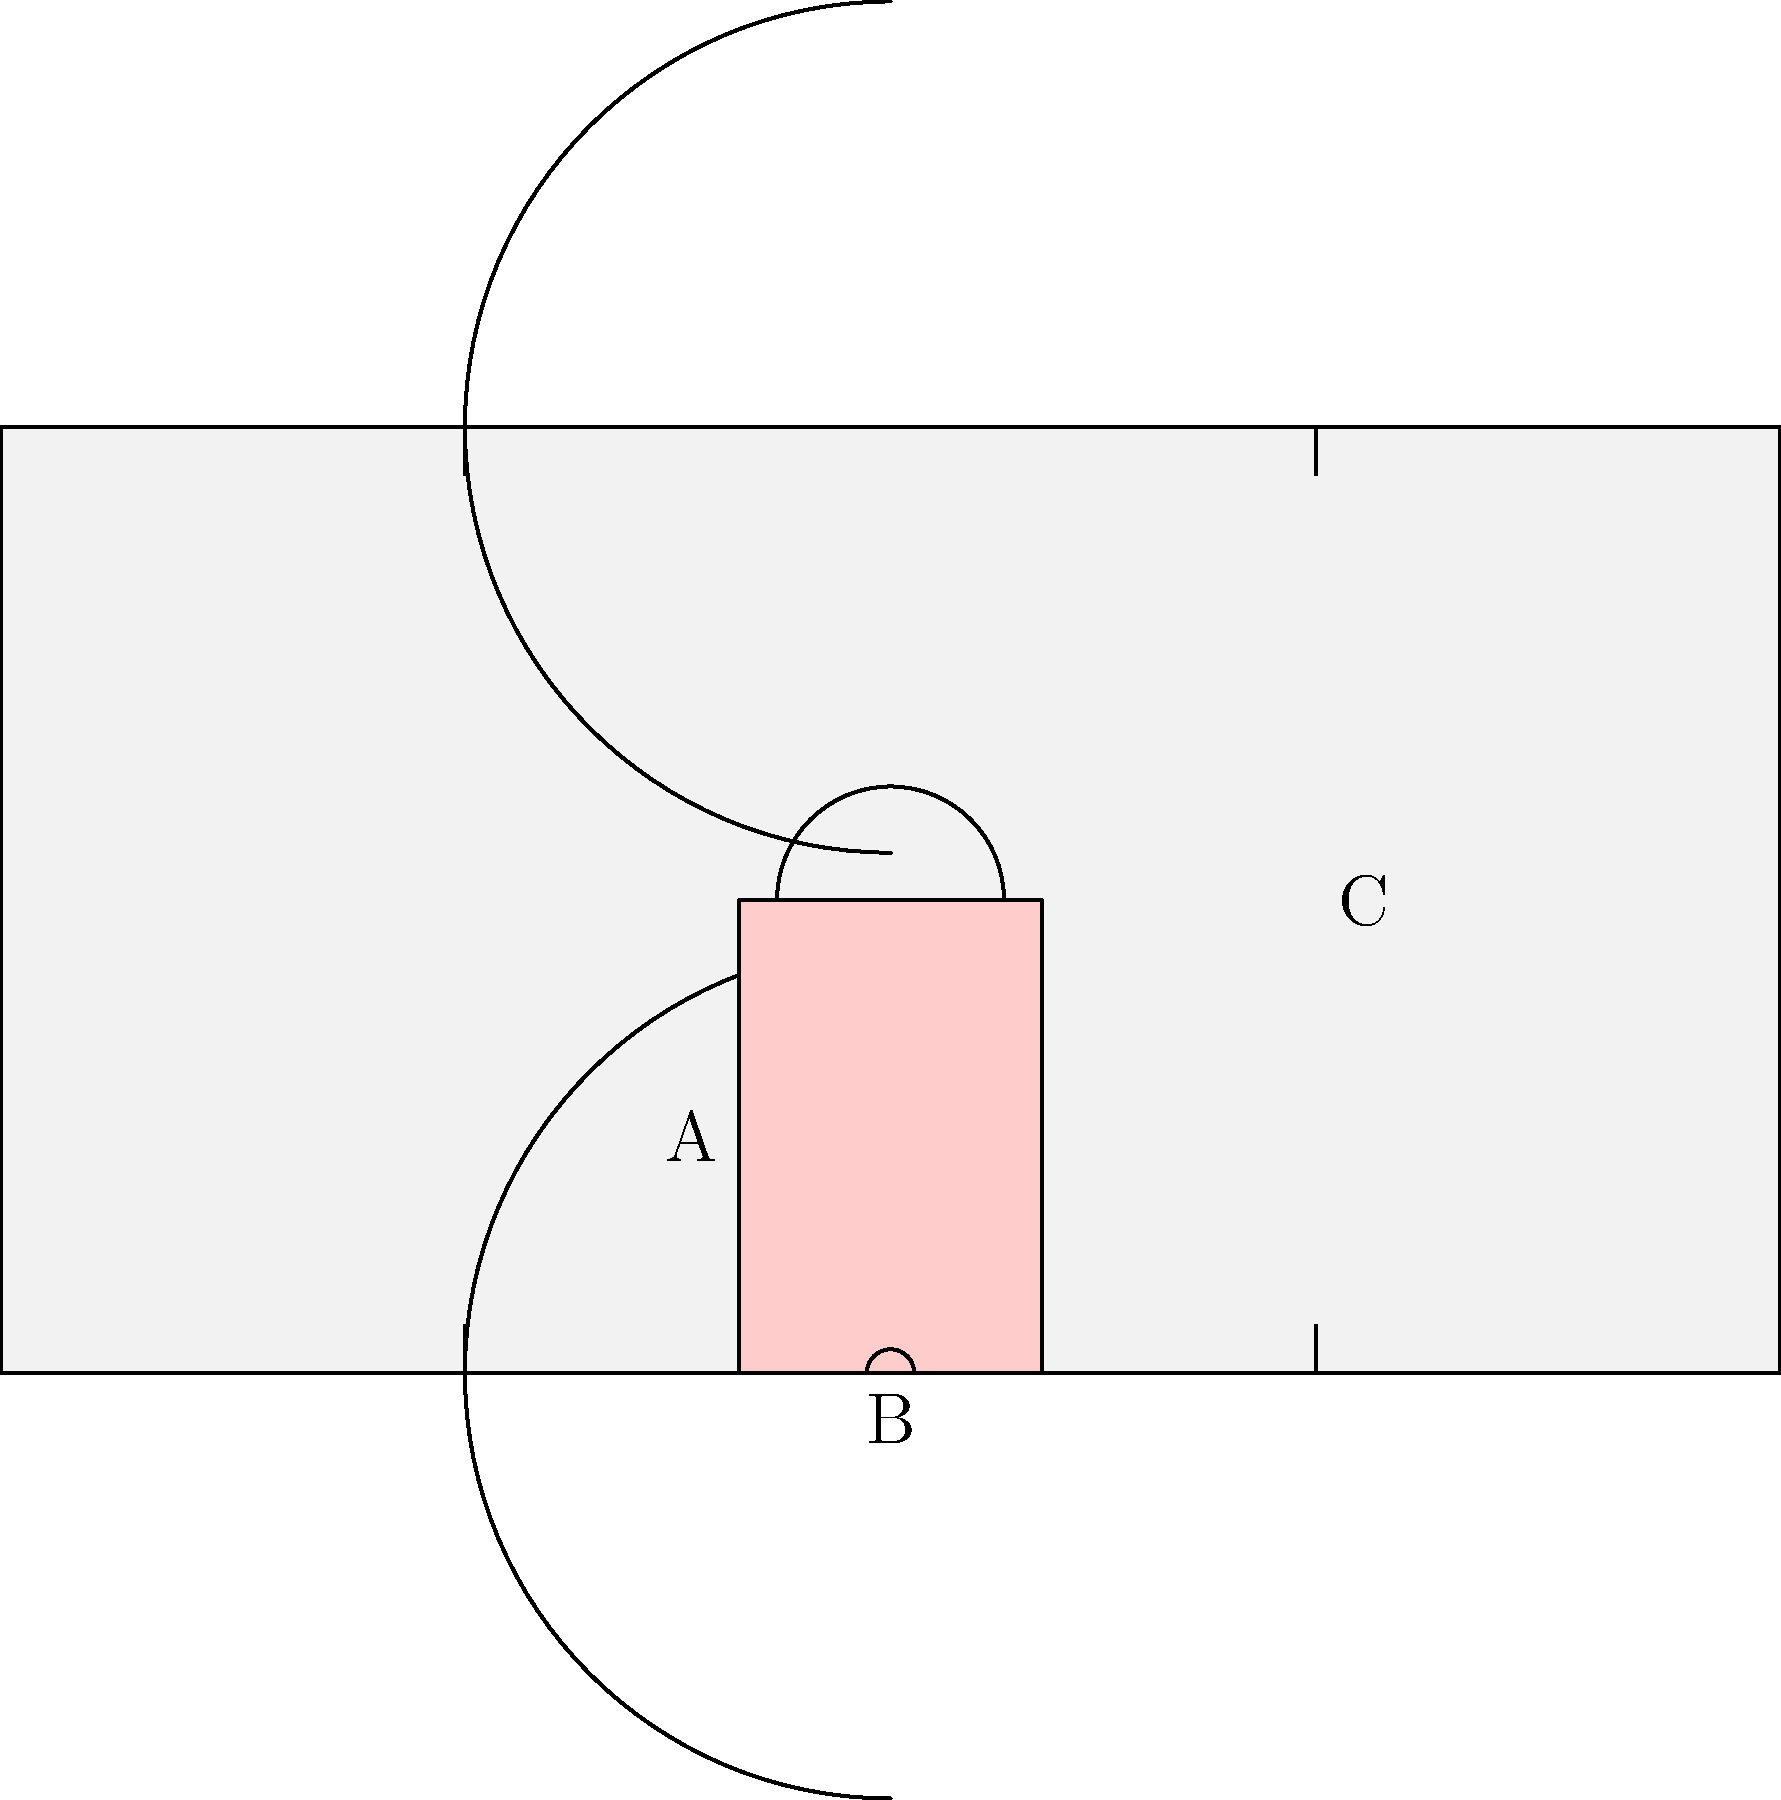In the women's basketball court diagram above, what is the distance in feet between point A and point B? To find the distance between point A and point B, we need to follow these steps:

1. Identify the locations of points A and B:
   - Point A is at the edge of the key (free throw lane)
   - Point B is at the baseline (end line) of the court

2. Recall the standard dimensions of a women's basketball court:
   - The key is 16 feet wide
   - The key extends 19 feet from the baseline to the free throw line

3. Calculate the distance:
   - Point A is at the edge of the key, which is 8 feet from the center of the court (half of 16 feet)
   - Point B is at the baseline, which is 25 feet from the center of the court
   - The distance between A and B is the difference between these two measurements

4. Perform the calculation:
   $$ \text{Distance} = 25 \text{ feet} - 8 \text{ feet} = 17 \text{ feet} $$

Therefore, the distance between point A and point B is 17 feet.
Answer: 17 feet 